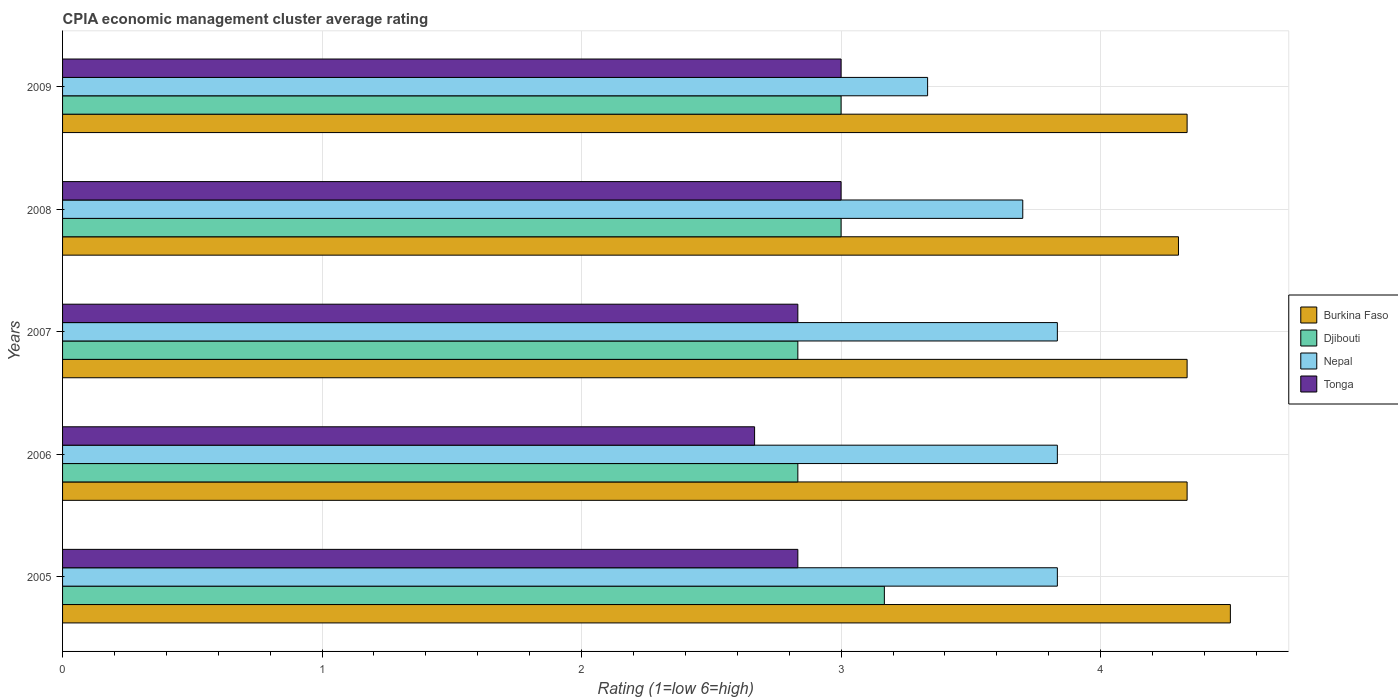How many groups of bars are there?
Offer a very short reply. 5. Are the number of bars on each tick of the Y-axis equal?
Provide a short and direct response. Yes. How many bars are there on the 5th tick from the top?
Offer a very short reply. 4. What is the label of the 5th group of bars from the top?
Your response must be concise. 2005. In how many cases, is the number of bars for a given year not equal to the number of legend labels?
Your response must be concise. 0. What is the CPIA rating in Nepal in 2009?
Offer a very short reply. 3.33. Across all years, what is the minimum CPIA rating in Nepal?
Offer a terse response. 3.33. In which year was the CPIA rating in Burkina Faso maximum?
Give a very brief answer. 2005. What is the total CPIA rating in Burkina Faso in the graph?
Provide a short and direct response. 21.8. What is the difference between the CPIA rating in Djibouti in 2008 and that in 2009?
Keep it short and to the point. 0. What is the difference between the CPIA rating in Tonga in 2009 and the CPIA rating in Nepal in 2007?
Provide a short and direct response. -0.83. What is the average CPIA rating in Nepal per year?
Ensure brevity in your answer.  3.71. In the year 2006, what is the difference between the CPIA rating in Burkina Faso and CPIA rating in Tonga?
Provide a succinct answer. 1.67. In how many years, is the CPIA rating in Nepal greater than 2.4 ?
Offer a very short reply. 5. What is the ratio of the CPIA rating in Nepal in 2007 to that in 2008?
Your answer should be compact. 1.04. What is the difference between the highest and the second highest CPIA rating in Burkina Faso?
Keep it short and to the point. 0.17. What is the difference between the highest and the lowest CPIA rating in Nepal?
Ensure brevity in your answer.  0.5. What does the 4th bar from the top in 2006 represents?
Keep it short and to the point. Burkina Faso. What does the 4th bar from the bottom in 2005 represents?
Your answer should be very brief. Tonga. How many bars are there?
Provide a succinct answer. 20. Are all the bars in the graph horizontal?
Your answer should be compact. Yes. Are the values on the major ticks of X-axis written in scientific E-notation?
Ensure brevity in your answer.  No. Does the graph contain any zero values?
Offer a terse response. No. How many legend labels are there?
Provide a succinct answer. 4. How are the legend labels stacked?
Ensure brevity in your answer.  Vertical. What is the title of the graph?
Keep it short and to the point. CPIA economic management cluster average rating. What is the label or title of the X-axis?
Provide a short and direct response. Rating (1=low 6=high). What is the label or title of the Y-axis?
Offer a very short reply. Years. What is the Rating (1=low 6=high) of Djibouti in 2005?
Offer a very short reply. 3.17. What is the Rating (1=low 6=high) of Nepal in 2005?
Provide a short and direct response. 3.83. What is the Rating (1=low 6=high) in Tonga in 2005?
Make the answer very short. 2.83. What is the Rating (1=low 6=high) of Burkina Faso in 2006?
Keep it short and to the point. 4.33. What is the Rating (1=low 6=high) in Djibouti in 2006?
Your answer should be very brief. 2.83. What is the Rating (1=low 6=high) in Nepal in 2006?
Provide a succinct answer. 3.83. What is the Rating (1=low 6=high) of Tonga in 2006?
Your response must be concise. 2.67. What is the Rating (1=low 6=high) of Burkina Faso in 2007?
Make the answer very short. 4.33. What is the Rating (1=low 6=high) of Djibouti in 2007?
Offer a very short reply. 2.83. What is the Rating (1=low 6=high) in Nepal in 2007?
Offer a very short reply. 3.83. What is the Rating (1=low 6=high) in Tonga in 2007?
Provide a short and direct response. 2.83. What is the Rating (1=low 6=high) of Nepal in 2008?
Offer a terse response. 3.7. What is the Rating (1=low 6=high) in Tonga in 2008?
Your response must be concise. 3. What is the Rating (1=low 6=high) in Burkina Faso in 2009?
Provide a succinct answer. 4.33. What is the Rating (1=low 6=high) in Nepal in 2009?
Ensure brevity in your answer.  3.33. What is the Rating (1=low 6=high) in Tonga in 2009?
Keep it short and to the point. 3. Across all years, what is the maximum Rating (1=low 6=high) in Burkina Faso?
Give a very brief answer. 4.5. Across all years, what is the maximum Rating (1=low 6=high) in Djibouti?
Offer a terse response. 3.17. Across all years, what is the maximum Rating (1=low 6=high) of Nepal?
Make the answer very short. 3.83. Across all years, what is the maximum Rating (1=low 6=high) of Tonga?
Keep it short and to the point. 3. Across all years, what is the minimum Rating (1=low 6=high) of Djibouti?
Your answer should be very brief. 2.83. Across all years, what is the minimum Rating (1=low 6=high) in Nepal?
Ensure brevity in your answer.  3.33. Across all years, what is the minimum Rating (1=low 6=high) in Tonga?
Provide a short and direct response. 2.67. What is the total Rating (1=low 6=high) of Burkina Faso in the graph?
Your response must be concise. 21.8. What is the total Rating (1=low 6=high) of Djibouti in the graph?
Your answer should be very brief. 14.83. What is the total Rating (1=low 6=high) in Nepal in the graph?
Keep it short and to the point. 18.53. What is the total Rating (1=low 6=high) in Tonga in the graph?
Your answer should be very brief. 14.33. What is the difference between the Rating (1=low 6=high) of Djibouti in 2005 and that in 2006?
Your answer should be very brief. 0.33. What is the difference between the Rating (1=low 6=high) in Nepal in 2005 and that in 2006?
Ensure brevity in your answer.  0. What is the difference between the Rating (1=low 6=high) in Tonga in 2005 and that in 2006?
Your response must be concise. 0.17. What is the difference between the Rating (1=low 6=high) in Burkina Faso in 2005 and that in 2007?
Your answer should be compact. 0.17. What is the difference between the Rating (1=low 6=high) in Djibouti in 2005 and that in 2007?
Ensure brevity in your answer.  0.33. What is the difference between the Rating (1=low 6=high) of Djibouti in 2005 and that in 2008?
Provide a short and direct response. 0.17. What is the difference between the Rating (1=low 6=high) of Nepal in 2005 and that in 2008?
Your answer should be very brief. 0.13. What is the difference between the Rating (1=low 6=high) in Tonga in 2005 and that in 2009?
Your answer should be very brief. -0.17. What is the difference between the Rating (1=low 6=high) of Djibouti in 2006 and that in 2007?
Make the answer very short. 0. What is the difference between the Rating (1=low 6=high) of Nepal in 2006 and that in 2007?
Offer a very short reply. 0. What is the difference between the Rating (1=low 6=high) in Djibouti in 2006 and that in 2008?
Your response must be concise. -0.17. What is the difference between the Rating (1=low 6=high) of Nepal in 2006 and that in 2008?
Your response must be concise. 0.13. What is the difference between the Rating (1=low 6=high) in Djibouti in 2006 and that in 2009?
Ensure brevity in your answer.  -0.17. What is the difference between the Rating (1=low 6=high) of Tonga in 2006 and that in 2009?
Give a very brief answer. -0.33. What is the difference between the Rating (1=low 6=high) in Burkina Faso in 2007 and that in 2008?
Your answer should be compact. 0.03. What is the difference between the Rating (1=low 6=high) in Nepal in 2007 and that in 2008?
Provide a succinct answer. 0.13. What is the difference between the Rating (1=low 6=high) in Burkina Faso in 2008 and that in 2009?
Your answer should be very brief. -0.03. What is the difference between the Rating (1=low 6=high) in Djibouti in 2008 and that in 2009?
Your answer should be very brief. 0. What is the difference between the Rating (1=low 6=high) of Nepal in 2008 and that in 2009?
Offer a terse response. 0.37. What is the difference between the Rating (1=low 6=high) of Burkina Faso in 2005 and the Rating (1=low 6=high) of Tonga in 2006?
Make the answer very short. 1.83. What is the difference between the Rating (1=low 6=high) in Djibouti in 2005 and the Rating (1=low 6=high) in Nepal in 2006?
Ensure brevity in your answer.  -0.67. What is the difference between the Rating (1=low 6=high) of Djibouti in 2005 and the Rating (1=low 6=high) of Tonga in 2006?
Offer a very short reply. 0.5. What is the difference between the Rating (1=low 6=high) of Burkina Faso in 2005 and the Rating (1=low 6=high) of Nepal in 2007?
Give a very brief answer. 0.67. What is the difference between the Rating (1=low 6=high) in Burkina Faso in 2005 and the Rating (1=low 6=high) in Tonga in 2007?
Your answer should be very brief. 1.67. What is the difference between the Rating (1=low 6=high) of Nepal in 2005 and the Rating (1=low 6=high) of Tonga in 2007?
Keep it short and to the point. 1. What is the difference between the Rating (1=low 6=high) of Burkina Faso in 2005 and the Rating (1=low 6=high) of Djibouti in 2008?
Keep it short and to the point. 1.5. What is the difference between the Rating (1=low 6=high) of Burkina Faso in 2005 and the Rating (1=low 6=high) of Tonga in 2008?
Offer a terse response. 1.5. What is the difference between the Rating (1=low 6=high) of Djibouti in 2005 and the Rating (1=low 6=high) of Nepal in 2008?
Your response must be concise. -0.53. What is the difference between the Rating (1=low 6=high) in Burkina Faso in 2005 and the Rating (1=low 6=high) in Djibouti in 2009?
Keep it short and to the point. 1.5. What is the difference between the Rating (1=low 6=high) in Burkina Faso in 2005 and the Rating (1=low 6=high) in Nepal in 2009?
Make the answer very short. 1.17. What is the difference between the Rating (1=low 6=high) in Djibouti in 2005 and the Rating (1=low 6=high) in Nepal in 2009?
Give a very brief answer. -0.17. What is the difference between the Rating (1=low 6=high) of Nepal in 2005 and the Rating (1=low 6=high) of Tonga in 2009?
Provide a succinct answer. 0.83. What is the difference between the Rating (1=low 6=high) of Burkina Faso in 2006 and the Rating (1=low 6=high) of Djibouti in 2007?
Keep it short and to the point. 1.5. What is the difference between the Rating (1=low 6=high) in Burkina Faso in 2006 and the Rating (1=low 6=high) in Tonga in 2007?
Provide a succinct answer. 1.5. What is the difference between the Rating (1=low 6=high) of Djibouti in 2006 and the Rating (1=low 6=high) of Tonga in 2007?
Offer a very short reply. 0. What is the difference between the Rating (1=low 6=high) in Nepal in 2006 and the Rating (1=low 6=high) in Tonga in 2007?
Keep it short and to the point. 1. What is the difference between the Rating (1=low 6=high) of Burkina Faso in 2006 and the Rating (1=low 6=high) of Djibouti in 2008?
Make the answer very short. 1.33. What is the difference between the Rating (1=low 6=high) of Burkina Faso in 2006 and the Rating (1=low 6=high) of Nepal in 2008?
Give a very brief answer. 0.63. What is the difference between the Rating (1=low 6=high) in Burkina Faso in 2006 and the Rating (1=low 6=high) in Tonga in 2008?
Your answer should be very brief. 1.33. What is the difference between the Rating (1=low 6=high) of Djibouti in 2006 and the Rating (1=low 6=high) of Nepal in 2008?
Give a very brief answer. -0.87. What is the difference between the Rating (1=low 6=high) of Djibouti in 2006 and the Rating (1=low 6=high) of Tonga in 2008?
Make the answer very short. -0.17. What is the difference between the Rating (1=low 6=high) in Nepal in 2006 and the Rating (1=low 6=high) in Tonga in 2008?
Keep it short and to the point. 0.83. What is the difference between the Rating (1=low 6=high) of Burkina Faso in 2006 and the Rating (1=low 6=high) of Nepal in 2009?
Your answer should be compact. 1. What is the difference between the Rating (1=low 6=high) of Burkina Faso in 2006 and the Rating (1=low 6=high) of Tonga in 2009?
Keep it short and to the point. 1.33. What is the difference between the Rating (1=low 6=high) in Burkina Faso in 2007 and the Rating (1=low 6=high) in Djibouti in 2008?
Your response must be concise. 1.33. What is the difference between the Rating (1=low 6=high) of Burkina Faso in 2007 and the Rating (1=low 6=high) of Nepal in 2008?
Provide a short and direct response. 0.63. What is the difference between the Rating (1=low 6=high) in Burkina Faso in 2007 and the Rating (1=low 6=high) in Tonga in 2008?
Your response must be concise. 1.33. What is the difference between the Rating (1=low 6=high) of Djibouti in 2007 and the Rating (1=low 6=high) of Nepal in 2008?
Give a very brief answer. -0.87. What is the difference between the Rating (1=low 6=high) in Djibouti in 2007 and the Rating (1=low 6=high) in Tonga in 2008?
Keep it short and to the point. -0.17. What is the difference between the Rating (1=low 6=high) in Burkina Faso in 2007 and the Rating (1=low 6=high) in Nepal in 2009?
Give a very brief answer. 1. What is the difference between the Rating (1=low 6=high) in Djibouti in 2007 and the Rating (1=low 6=high) in Nepal in 2009?
Provide a short and direct response. -0.5. What is the difference between the Rating (1=low 6=high) of Djibouti in 2007 and the Rating (1=low 6=high) of Tonga in 2009?
Provide a short and direct response. -0.17. What is the difference between the Rating (1=low 6=high) of Burkina Faso in 2008 and the Rating (1=low 6=high) of Djibouti in 2009?
Your response must be concise. 1.3. What is the difference between the Rating (1=low 6=high) in Burkina Faso in 2008 and the Rating (1=low 6=high) in Nepal in 2009?
Offer a terse response. 0.97. What is the difference between the Rating (1=low 6=high) of Burkina Faso in 2008 and the Rating (1=low 6=high) of Tonga in 2009?
Your answer should be very brief. 1.3. What is the difference between the Rating (1=low 6=high) of Djibouti in 2008 and the Rating (1=low 6=high) of Nepal in 2009?
Make the answer very short. -0.33. What is the difference between the Rating (1=low 6=high) in Nepal in 2008 and the Rating (1=low 6=high) in Tonga in 2009?
Offer a very short reply. 0.7. What is the average Rating (1=low 6=high) in Burkina Faso per year?
Your answer should be very brief. 4.36. What is the average Rating (1=low 6=high) in Djibouti per year?
Your answer should be very brief. 2.97. What is the average Rating (1=low 6=high) in Nepal per year?
Give a very brief answer. 3.71. What is the average Rating (1=low 6=high) of Tonga per year?
Provide a short and direct response. 2.87. In the year 2005, what is the difference between the Rating (1=low 6=high) in Djibouti and Rating (1=low 6=high) in Nepal?
Offer a terse response. -0.67. In the year 2005, what is the difference between the Rating (1=low 6=high) of Nepal and Rating (1=low 6=high) of Tonga?
Keep it short and to the point. 1. In the year 2006, what is the difference between the Rating (1=low 6=high) of Burkina Faso and Rating (1=low 6=high) of Djibouti?
Make the answer very short. 1.5. In the year 2006, what is the difference between the Rating (1=low 6=high) of Burkina Faso and Rating (1=low 6=high) of Tonga?
Give a very brief answer. 1.67. In the year 2006, what is the difference between the Rating (1=low 6=high) of Djibouti and Rating (1=low 6=high) of Tonga?
Offer a terse response. 0.17. In the year 2006, what is the difference between the Rating (1=low 6=high) in Nepal and Rating (1=low 6=high) in Tonga?
Your response must be concise. 1.17. In the year 2007, what is the difference between the Rating (1=low 6=high) of Djibouti and Rating (1=low 6=high) of Nepal?
Your answer should be very brief. -1. In the year 2008, what is the difference between the Rating (1=low 6=high) in Burkina Faso and Rating (1=low 6=high) in Djibouti?
Make the answer very short. 1.3. In the year 2008, what is the difference between the Rating (1=low 6=high) in Burkina Faso and Rating (1=low 6=high) in Nepal?
Provide a short and direct response. 0.6. In the year 2008, what is the difference between the Rating (1=low 6=high) of Burkina Faso and Rating (1=low 6=high) of Tonga?
Keep it short and to the point. 1.3. In the year 2008, what is the difference between the Rating (1=low 6=high) in Djibouti and Rating (1=low 6=high) in Nepal?
Make the answer very short. -0.7. In the year 2008, what is the difference between the Rating (1=low 6=high) of Djibouti and Rating (1=low 6=high) of Tonga?
Provide a short and direct response. 0. In the year 2009, what is the difference between the Rating (1=low 6=high) in Burkina Faso and Rating (1=low 6=high) in Nepal?
Make the answer very short. 1. In the year 2009, what is the difference between the Rating (1=low 6=high) in Burkina Faso and Rating (1=low 6=high) in Tonga?
Offer a terse response. 1.33. What is the ratio of the Rating (1=low 6=high) of Burkina Faso in 2005 to that in 2006?
Give a very brief answer. 1.04. What is the ratio of the Rating (1=low 6=high) of Djibouti in 2005 to that in 2006?
Give a very brief answer. 1.12. What is the ratio of the Rating (1=low 6=high) in Nepal in 2005 to that in 2006?
Make the answer very short. 1. What is the ratio of the Rating (1=low 6=high) in Tonga in 2005 to that in 2006?
Your response must be concise. 1.06. What is the ratio of the Rating (1=low 6=high) in Djibouti in 2005 to that in 2007?
Offer a terse response. 1.12. What is the ratio of the Rating (1=low 6=high) of Nepal in 2005 to that in 2007?
Your answer should be very brief. 1. What is the ratio of the Rating (1=low 6=high) in Burkina Faso in 2005 to that in 2008?
Keep it short and to the point. 1.05. What is the ratio of the Rating (1=low 6=high) in Djibouti in 2005 to that in 2008?
Give a very brief answer. 1.06. What is the ratio of the Rating (1=low 6=high) of Nepal in 2005 to that in 2008?
Offer a terse response. 1.04. What is the ratio of the Rating (1=low 6=high) of Tonga in 2005 to that in 2008?
Give a very brief answer. 0.94. What is the ratio of the Rating (1=low 6=high) in Burkina Faso in 2005 to that in 2009?
Offer a very short reply. 1.04. What is the ratio of the Rating (1=low 6=high) in Djibouti in 2005 to that in 2009?
Provide a succinct answer. 1.06. What is the ratio of the Rating (1=low 6=high) in Nepal in 2005 to that in 2009?
Ensure brevity in your answer.  1.15. What is the ratio of the Rating (1=low 6=high) in Djibouti in 2006 to that in 2007?
Provide a succinct answer. 1. What is the ratio of the Rating (1=low 6=high) of Nepal in 2006 to that in 2007?
Your answer should be compact. 1. What is the ratio of the Rating (1=low 6=high) in Burkina Faso in 2006 to that in 2008?
Give a very brief answer. 1.01. What is the ratio of the Rating (1=low 6=high) in Nepal in 2006 to that in 2008?
Offer a very short reply. 1.04. What is the ratio of the Rating (1=low 6=high) of Tonga in 2006 to that in 2008?
Your answer should be compact. 0.89. What is the ratio of the Rating (1=low 6=high) in Burkina Faso in 2006 to that in 2009?
Provide a succinct answer. 1. What is the ratio of the Rating (1=low 6=high) of Nepal in 2006 to that in 2009?
Your answer should be compact. 1.15. What is the ratio of the Rating (1=low 6=high) in Tonga in 2006 to that in 2009?
Provide a succinct answer. 0.89. What is the ratio of the Rating (1=low 6=high) of Nepal in 2007 to that in 2008?
Provide a short and direct response. 1.04. What is the ratio of the Rating (1=low 6=high) of Tonga in 2007 to that in 2008?
Offer a terse response. 0.94. What is the ratio of the Rating (1=low 6=high) of Djibouti in 2007 to that in 2009?
Offer a terse response. 0.94. What is the ratio of the Rating (1=low 6=high) in Nepal in 2007 to that in 2009?
Provide a short and direct response. 1.15. What is the ratio of the Rating (1=low 6=high) of Nepal in 2008 to that in 2009?
Ensure brevity in your answer.  1.11. What is the difference between the highest and the lowest Rating (1=low 6=high) in Burkina Faso?
Offer a terse response. 0.2. What is the difference between the highest and the lowest Rating (1=low 6=high) of Djibouti?
Your answer should be very brief. 0.33. What is the difference between the highest and the lowest Rating (1=low 6=high) of Nepal?
Provide a succinct answer. 0.5. What is the difference between the highest and the lowest Rating (1=low 6=high) of Tonga?
Give a very brief answer. 0.33. 